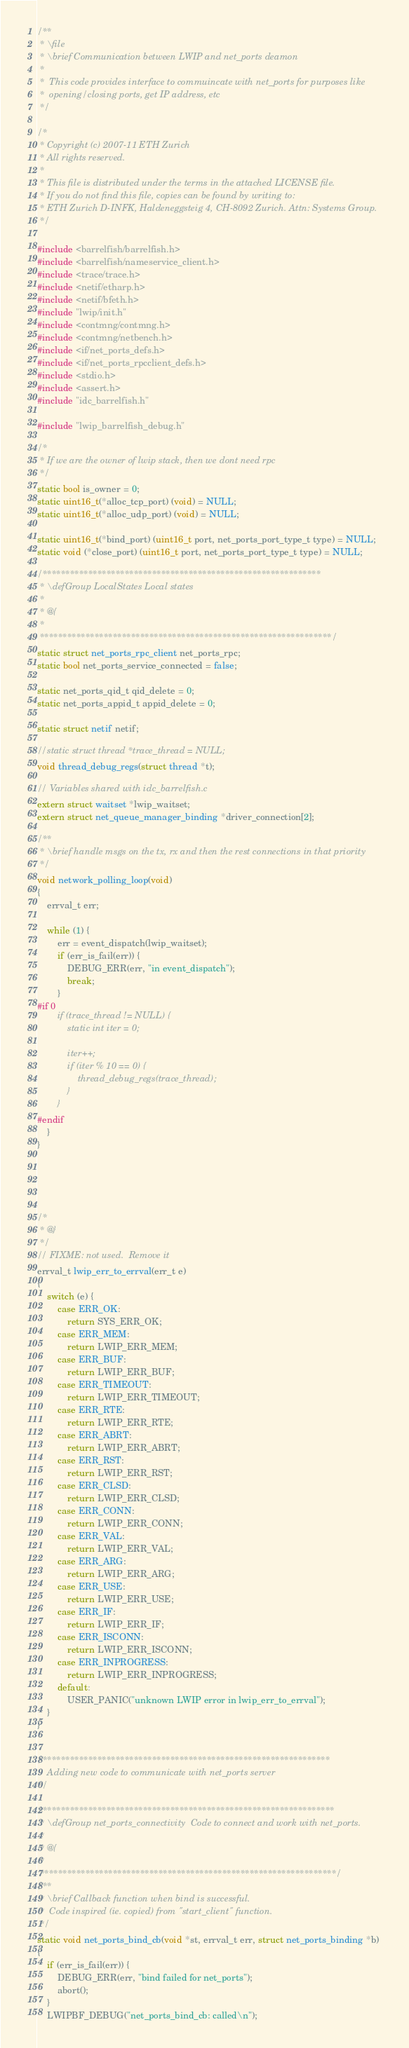<code> <loc_0><loc_0><loc_500><loc_500><_C_>/**
 * \file
 * \brief Communication between LWIP and net_ports deamon
 *
 *  This code provides interface to commuincate with net_ports for purposes like
 *  opening/closing ports, get IP address, etc
 */

/*
 * Copyright (c) 2007-11 ETH Zurich
 * All rights reserved.
 *
 * This file is distributed under the terms in the attached LICENSE file.
 * If you do not find this file, copies can be found by writing to:
 * ETH Zurich D-INFK, Haldeneggsteig 4, CH-8092 Zurich. Attn: Systems Group.
 */

#include <barrelfish/barrelfish.h>
#include <barrelfish/nameservice_client.h>
#include <trace/trace.h>
#include <netif/etharp.h>
#include <netif/bfeth.h>
#include "lwip/init.h"
#include <contmng/contmng.h>
#include <contmng/netbench.h>
#include <if/net_ports_defs.h>
#include <if/net_ports_rpcclient_defs.h>
#include <stdio.h>
#include <assert.h>
#include "idc_barrelfish.h"

#include "lwip_barrelfish_debug.h"

/*
 * If we are the owner of lwip stack, then we dont need rpc
 */
static bool is_owner = 0;
static uint16_t(*alloc_tcp_port) (void) = NULL;
static uint16_t(*alloc_udp_port) (void) = NULL;

static uint16_t(*bind_port) (uint16_t port, net_ports_port_type_t type) = NULL;
static void (*close_port) (uint16_t port, net_ports_port_type_t type) = NULL;

/*************************************************************
 * \defGroup LocalStates Local states
 *
 * @{
 *
 ****************************************************************/
static struct net_ports_rpc_client net_ports_rpc;
static bool net_ports_service_connected = false;

static net_ports_qid_t qid_delete = 0;
static net_ports_appid_t appid_delete = 0;

static struct netif netif;

//static struct thread *trace_thread = NULL;
void thread_debug_regs(struct thread *t);

// Variables shared with idc_barrelfish.c
extern struct waitset *lwip_waitset;
extern struct net_queue_manager_binding *driver_connection[2];

/**
 * \brief handle msgs on the tx, rx and then the rest connections in that priority
 */
void network_polling_loop(void)
{
    errval_t err;

    while (1) {
        err = event_dispatch(lwip_waitset);
        if (err_is_fail(err)) {
            DEBUG_ERR(err, "in event_dispatch");
            break;
        }
#if 0
        if (trace_thread != NULL) {
            static int iter = 0;

            iter++;
            if (iter % 10 == 0) {
                thread_debug_regs(trace_thread);
            }
        }
#endif
    }
}





/*
 * @}
 */
// FIXME: not used.  Remove it
errval_t lwip_err_to_errval(err_t e)
{
    switch (e) {
        case ERR_OK:
            return SYS_ERR_OK;
        case ERR_MEM:
            return LWIP_ERR_MEM;
        case ERR_BUF:
            return LWIP_ERR_BUF;
        case ERR_TIMEOUT:
            return LWIP_ERR_TIMEOUT;
        case ERR_RTE:
            return LWIP_ERR_RTE;
        case ERR_ABRT:
            return LWIP_ERR_ABRT;
        case ERR_RST:
            return LWIP_ERR_RST;
        case ERR_CLSD:
            return LWIP_ERR_CLSD;
        case ERR_CONN:
            return LWIP_ERR_CONN;
        case ERR_VAL:
            return LWIP_ERR_VAL;
        case ERR_ARG:
            return LWIP_ERR_ARG;
        case ERR_USE:
            return LWIP_ERR_USE;
        case ERR_IF:
            return LWIP_ERR_IF;
        case ERR_ISCONN:
            return LWIP_ERR_ISCONN;
        case ERR_INPROGRESS:
            return LWIP_ERR_INPROGRESS;
        default:
            USER_PANIC("unknown LWIP error in lwip_err_to_errval");
    }
}


/***************************************************************
    Adding new code to communicate with net_ports server
*/

/****************************************************************
 * \defGroup net_ports_connectivity  Code to connect and work with net_ports.
 *
 * @{
 *
 *****************************************************************/
/**
 * \brief Callback function when bind is successful.
 *  Code inspired (ie. copied) from "start_client" function.
 */
static void net_ports_bind_cb(void *st, errval_t err, struct net_ports_binding *b)
{
    if (err_is_fail(err)) {
        DEBUG_ERR(err, "bind failed for net_ports");
        abort();
    }
    LWIPBF_DEBUG("net_ports_bind_cb: called\n");
</code> 